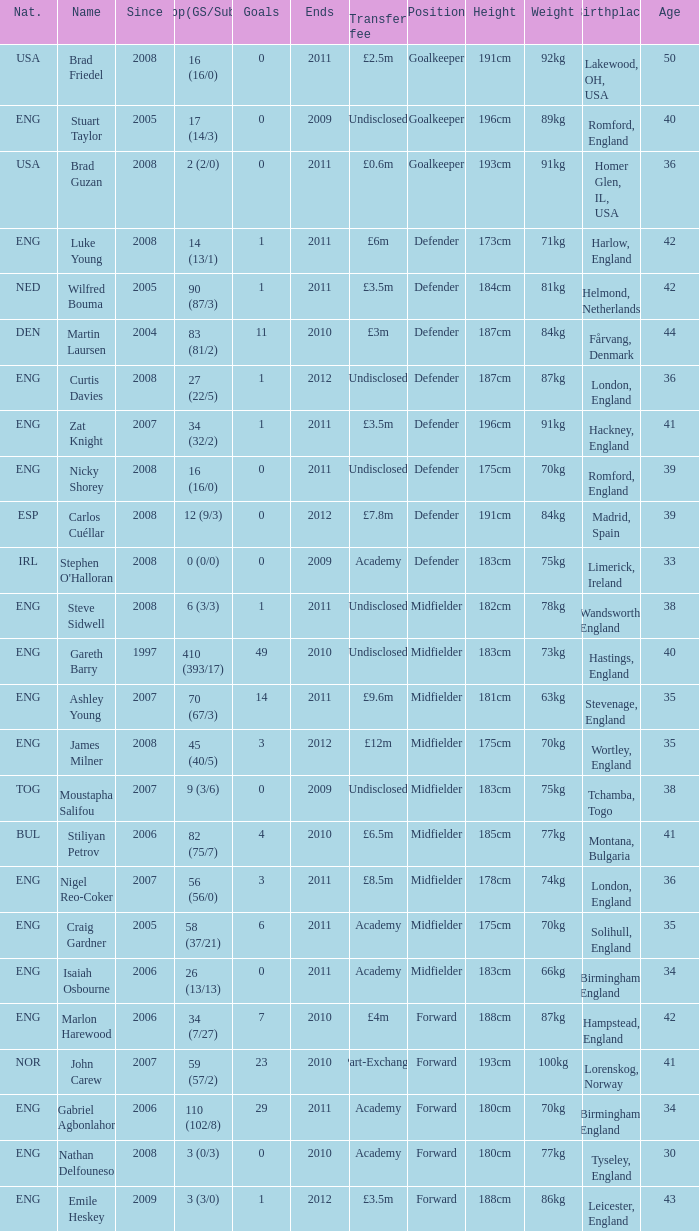When the transfer fee is £8.5m, what is the total ends? 2011.0. 